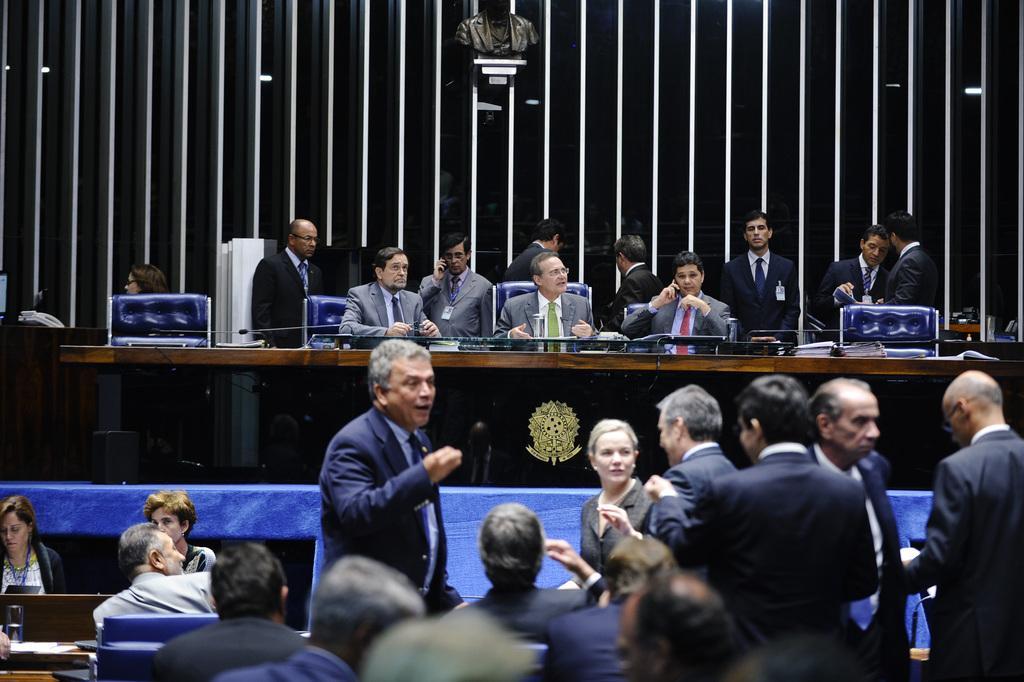Could you give a brief overview of what you see in this image? In this picture we can see a group of people sitting on the dais and discussing, speaking in their mobiles. In front of them there are few people standing and discussing. In the backdrop we have a statue. 